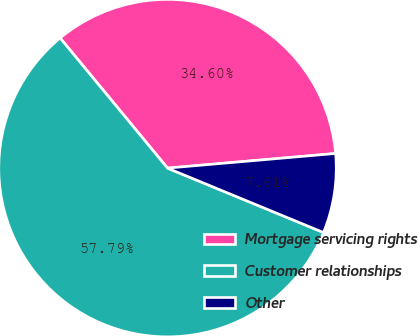Convert chart. <chart><loc_0><loc_0><loc_500><loc_500><pie_chart><fcel>Mortgage servicing rights<fcel>Customer relationships<fcel>Other<nl><fcel>34.6%<fcel>57.79%<fcel>7.61%<nl></chart> 